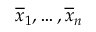Convert formula to latex. <formula><loc_0><loc_0><loc_500><loc_500>\overline { x } _ { 1 } , \dots , \overline { x } _ { n }</formula> 